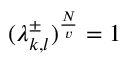<formula> <loc_0><loc_0><loc_500><loc_500>( \lambda _ { k , l } ^ { \pm } ) ^ { \frac { N } { v } } = 1</formula> 